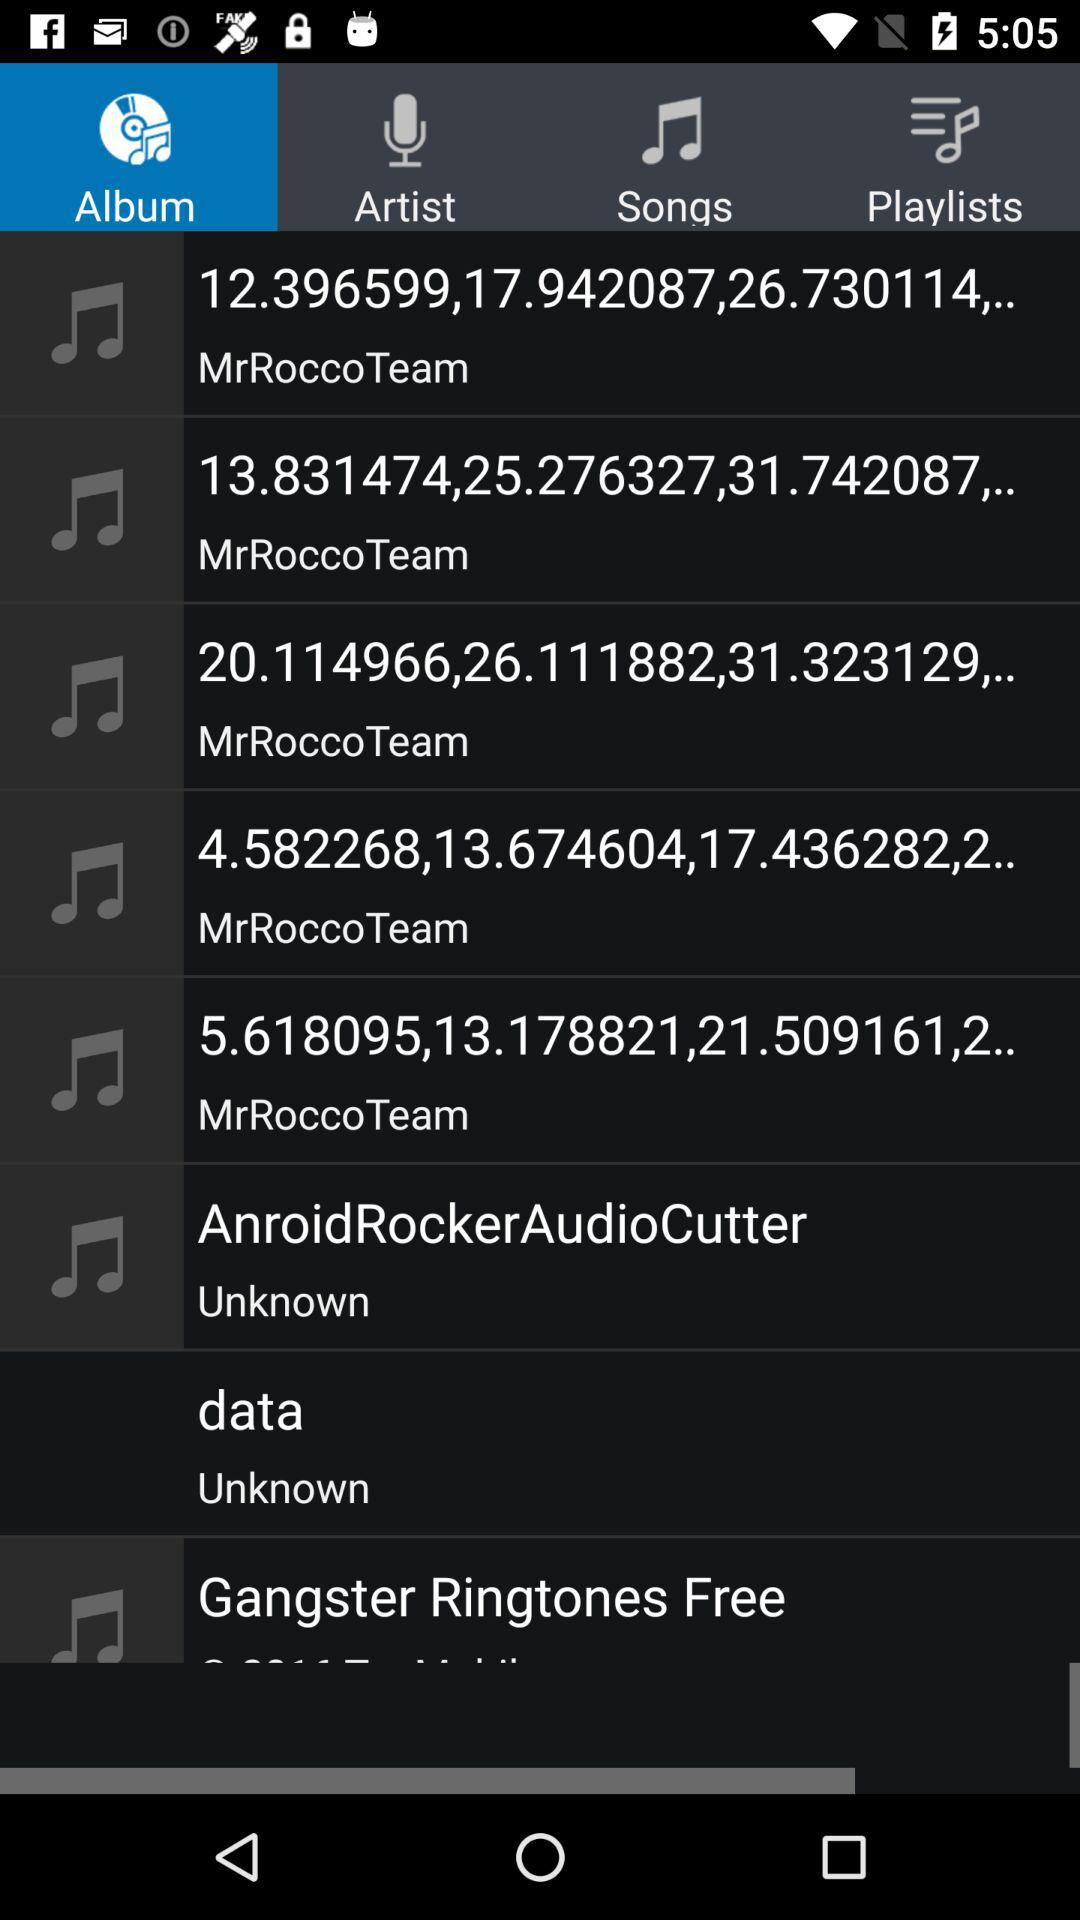Which option is selected? The selected option is "Album". 